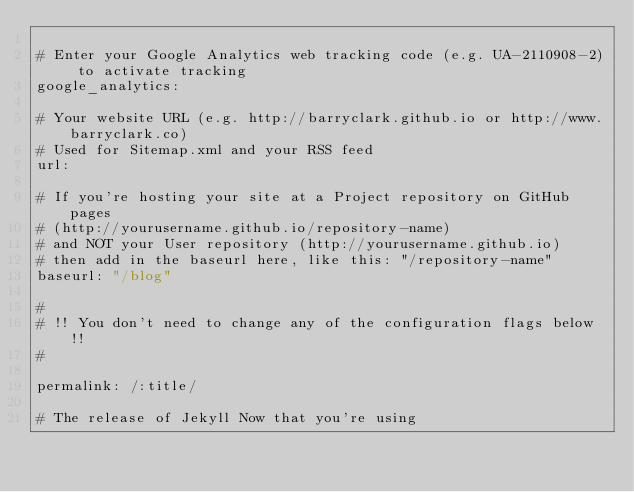<code> <loc_0><loc_0><loc_500><loc_500><_YAML_>
# Enter your Google Analytics web tracking code (e.g. UA-2110908-2) to activate tracking
google_analytics:

# Your website URL (e.g. http://barryclark.github.io or http://www.barryclark.co)
# Used for Sitemap.xml and your RSS feed
url:

# If you're hosting your site at a Project repository on GitHub pages
# (http://yourusername.github.io/repository-name)
# and NOT your User repository (http://yourusername.github.io)
# then add in the baseurl here, like this: "/repository-name"
baseurl: "/blog"

#
# !! You don't need to change any of the configuration flags below !!
#

permalink: /:title/

# The release of Jekyll Now that you're using</code> 